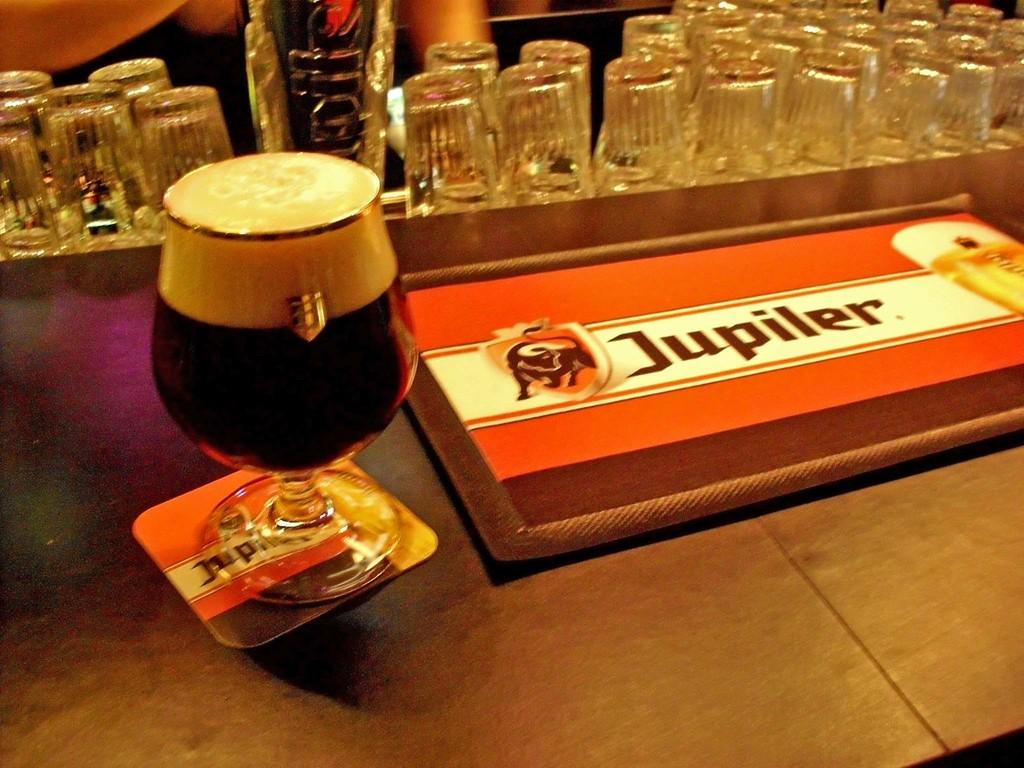<image>
Summarize the visual content of the image. A glass of Jupiler Beer on the counter at a bar. 